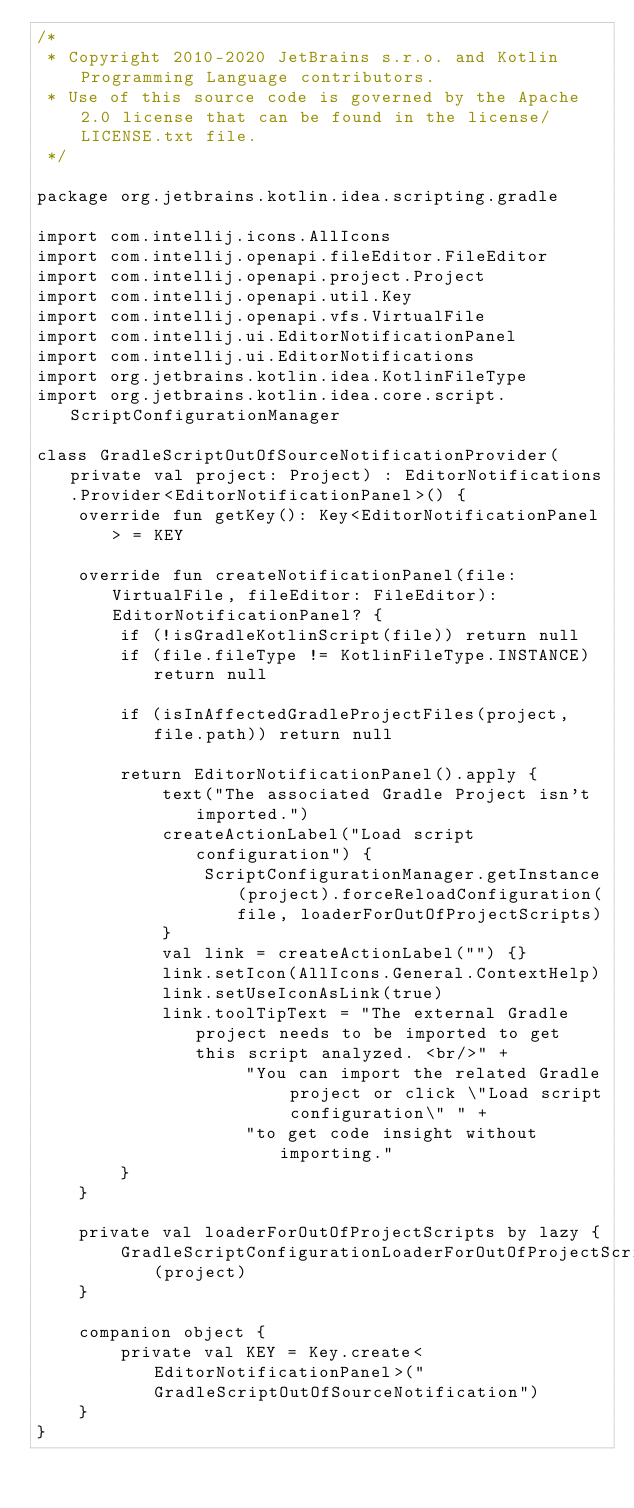Convert code to text. <code><loc_0><loc_0><loc_500><loc_500><_Kotlin_>/*
 * Copyright 2010-2020 JetBrains s.r.o. and Kotlin Programming Language contributors.
 * Use of this source code is governed by the Apache 2.0 license that can be found in the license/LICENSE.txt file.
 */

package org.jetbrains.kotlin.idea.scripting.gradle

import com.intellij.icons.AllIcons
import com.intellij.openapi.fileEditor.FileEditor
import com.intellij.openapi.project.Project
import com.intellij.openapi.util.Key
import com.intellij.openapi.vfs.VirtualFile
import com.intellij.ui.EditorNotificationPanel
import com.intellij.ui.EditorNotifications
import org.jetbrains.kotlin.idea.KotlinFileType
import org.jetbrains.kotlin.idea.core.script.ScriptConfigurationManager

class GradleScriptOutOfSourceNotificationProvider(private val project: Project) : EditorNotifications.Provider<EditorNotificationPanel>() {
    override fun getKey(): Key<EditorNotificationPanel> = KEY

    override fun createNotificationPanel(file: VirtualFile, fileEditor: FileEditor): EditorNotificationPanel? {
        if (!isGradleKotlinScript(file)) return null
        if (file.fileType != KotlinFileType.INSTANCE) return null

        if (isInAffectedGradleProjectFiles(project, file.path)) return null

        return EditorNotificationPanel().apply {
            text("The associated Gradle Project isn't imported.")
            createActionLabel("Load script configuration") {
                ScriptConfigurationManager.getInstance(project).forceReloadConfiguration(file, loaderForOutOfProjectScripts)
            }
            val link = createActionLabel("") {}
            link.setIcon(AllIcons.General.ContextHelp)
            link.setUseIconAsLink(true)
            link.toolTipText = "The external Gradle project needs to be imported to get this script analyzed. <br/>" +
                    "You can import the related Gradle project or click \"Load script configuration\" " +
                    "to get code insight without importing."
        }
    }

    private val loaderForOutOfProjectScripts by lazy {
        GradleScriptConfigurationLoaderForOutOfProjectScripts(project)
    }

    companion object {
        private val KEY = Key.create<EditorNotificationPanel>("GradleScriptOutOfSourceNotification")
    }
}</code> 